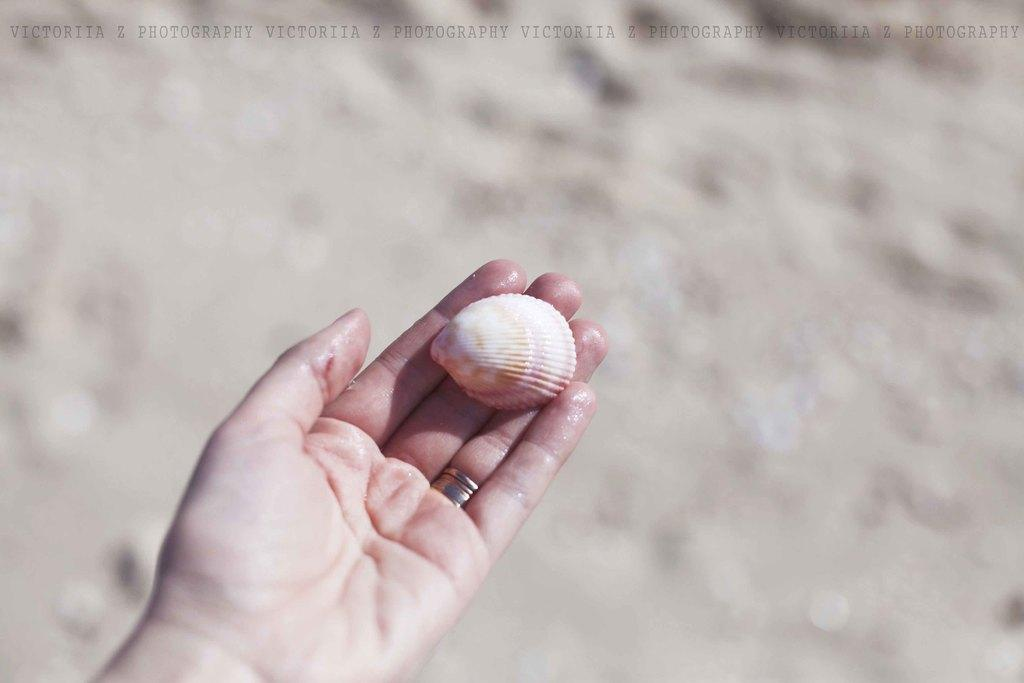What object is in the person's hand in the image? There is a shell in the person's hand in the image. What is visible at the top of the image? There is text visible at the top of the image. How would you describe the background of the image? The background of the image is blurred. Can you see the moon in the image? There is no moon visible in the image. How many eyes can be seen on the toys in the image? There are no toys present in the image. 